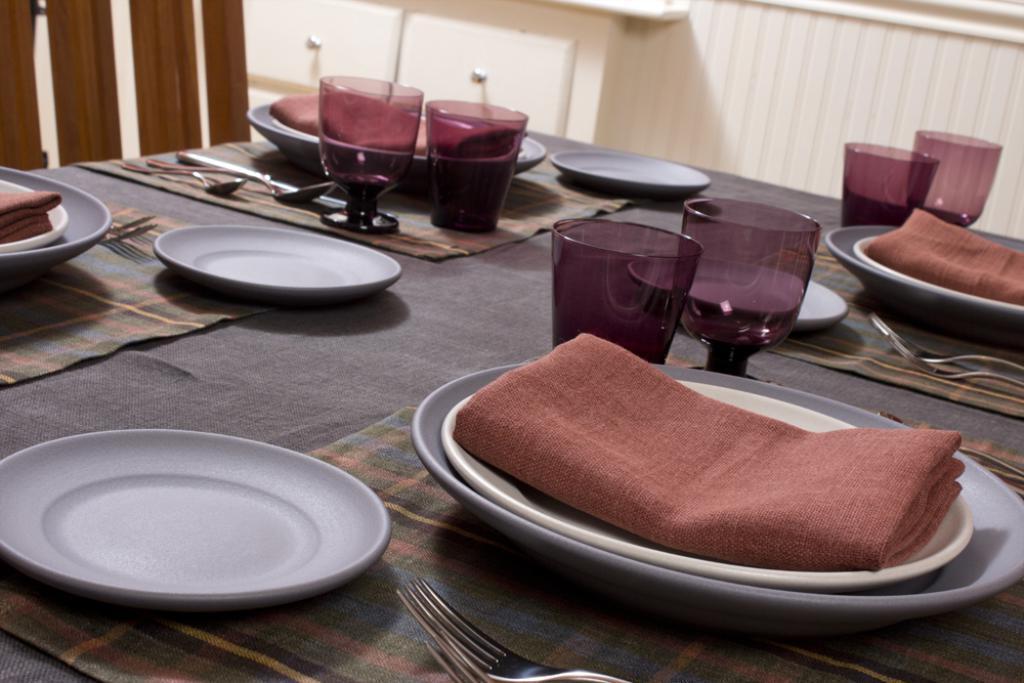Describe this image in one or two sentences. In this image I can see number of plates, chairs and spoons on this table. 